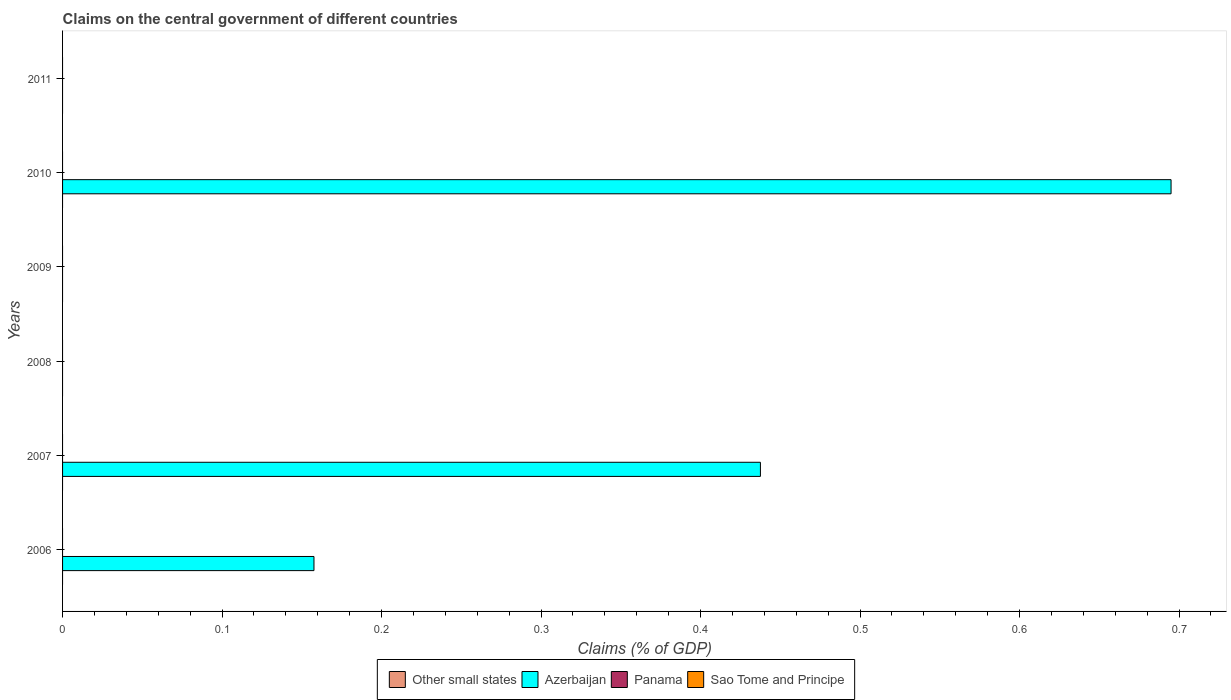How many different coloured bars are there?
Your response must be concise. 1. How many bars are there on the 4th tick from the top?
Your response must be concise. 0. What is the total percentage of GDP claimed on the central government in Azerbaijan in the graph?
Your response must be concise. 1.29. What is the difference between the percentage of GDP claimed on the central government in Azerbaijan in 2010 and the percentage of GDP claimed on the central government in Panama in 2007?
Keep it short and to the point. 0.69. What is the average percentage of GDP claimed on the central government in Azerbaijan per year?
Ensure brevity in your answer.  0.22. In how many years, is the percentage of GDP claimed on the central government in Panama greater than 0.08 %?
Your response must be concise. 0. What is the difference between the highest and the second highest percentage of GDP claimed on the central government in Azerbaijan?
Offer a terse response. 0.26. In how many years, is the percentage of GDP claimed on the central government in Other small states greater than the average percentage of GDP claimed on the central government in Other small states taken over all years?
Offer a very short reply. 0. Is it the case that in every year, the sum of the percentage of GDP claimed on the central government in Azerbaijan and percentage of GDP claimed on the central government in Panama is greater than the sum of percentage of GDP claimed on the central government in Sao Tome and Principe and percentage of GDP claimed on the central government in Other small states?
Give a very brief answer. No. Is it the case that in every year, the sum of the percentage of GDP claimed on the central government in Sao Tome and Principe and percentage of GDP claimed on the central government in Panama is greater than the percentage of GDP claimed on the central government in Other small states?
Your answer should be compact. No. How many bars are there?
Your answer should be very brief. 3. How many years are there in the graph?
Provide a succinct answer. 6. Does the graph contain any zero values?
Offer a terse response. Yes. Does the graph contain grids?
Keep it short and to the point. No. How are the legend labels stacked?
Provide a short and direct response. Horizontal. What is the title of the graph?
Provide a short and direct response. Claims on the central government of different countries. Does "Least developed countries" appear as one of the legend labels in the graph?
Ensure brevity in your answer.  No. What is the label or title of the X-axis?
Provide a succinct answer. Claims (% of GDP). What is the label or title of the Y-axis?
Your answer should be very brief. Years. What is the Claims (% of GDP) of Azerbaijan in 2006?
Your response must be concise. 0.16. What is the Claims (% of GDP) in Panama in 2006?
Your answer should be compact. 0. What is the Claims (% of GDP) of Sao Tome and Principe in 2006?
Offer a terse response. 0. What is the Claims (% of GDP) in Azerbaijan in 2007?
Make the answer very short. 0.44. What is the Claims (% of GDP) of Azerbaijan in 2008?
Offer a very short reply. 0. What is the Claims (% of GDP) in Panama in 2008?
Offer a very short reply. 0. What is the Claims (% of GDP) of Sao Tome and Principe in 2008?
Ensure brevity in your answer.  0. What is the Claims (% of GDP) of Other small states in 2009?
Offer a terse response. 0. What is the Claims (% of GDP) of Sao Tome and Principe in 2009?
Keep it short and to the point. 0. What is the Claims (% of GDP) in Other small states in 2010?
Ensure brevity in your answer.  0. What is the Claims (% of GDP) of Azerbaijan in 2010?
Provide a succinct answer. 0.69. What is the Claims (% of GDP) of Panama in 2011?
Keep it short and to the point. 0. What is the Claims (% of GDP) in Sao Tome and Principe in 2011?
Keep it short and to the point. 0. Across all years, what is the maximum Claims (% of GDP) in Azerbaijan?
Provide a short and direct response. 0.69. Across all years, what is the minimum Claims (% of GDP) of Azerbaijan?
Your response must be concise. 0. What is the total Claims (% of GDP) of Azerbaijan in the graph?
Keep it short and to the point. 1.29. What is the total Claims (% of GDP) in Sao Tome and Principe in the graph?
Provide a succinct answer. 0. What is the difference between the Claims (% of GDP) in Azerbaijan in 2006 and that in 2007?
Offer a terse response. -0.28. What is the difference between the Claims (% of GDP) of Azerbaijan in 2006 and that in 2010?
Your answer should be very brief. -0.54. What is the difference between the Claims (% of GDP) in Azerbaijan in 2007 and that in 2010?
Offer a terse response. -0.26. What is the average Claims (% of GDP) of Other small states per year?
Provide a succinct answer. 0. What is the average Claims (% of GDP) of Azerbaijan per year?
Make the answer very short. 0.21. What is the average Claims (% of GDP) in Sao Tome and Principe per year?
Offer a very short reply. 0. What is the ratio of the Claims (% of GDP) of Azerbaijan in 2006 to that in 2007?
Offer a terse response. 0.36. What is the ratio of the Claims (% of GDP) of Azerbaijan in 2006 to that in 2010?
Offer a very short reply. 0.23. What is the ratio of the Claims (% of GDP) in Azerbaijan in 2007 to that in 2010?
Provide a succinct answer. 0.63. What is the difference between the highest and the second highest Claims (% of GDP) of Azerbaijan?
Offer a terse response. 0.26. What is the difference between the highest and the lowest Claims (% of GDP) of Azerbaijan?
Make the answer very short. 0.69. 